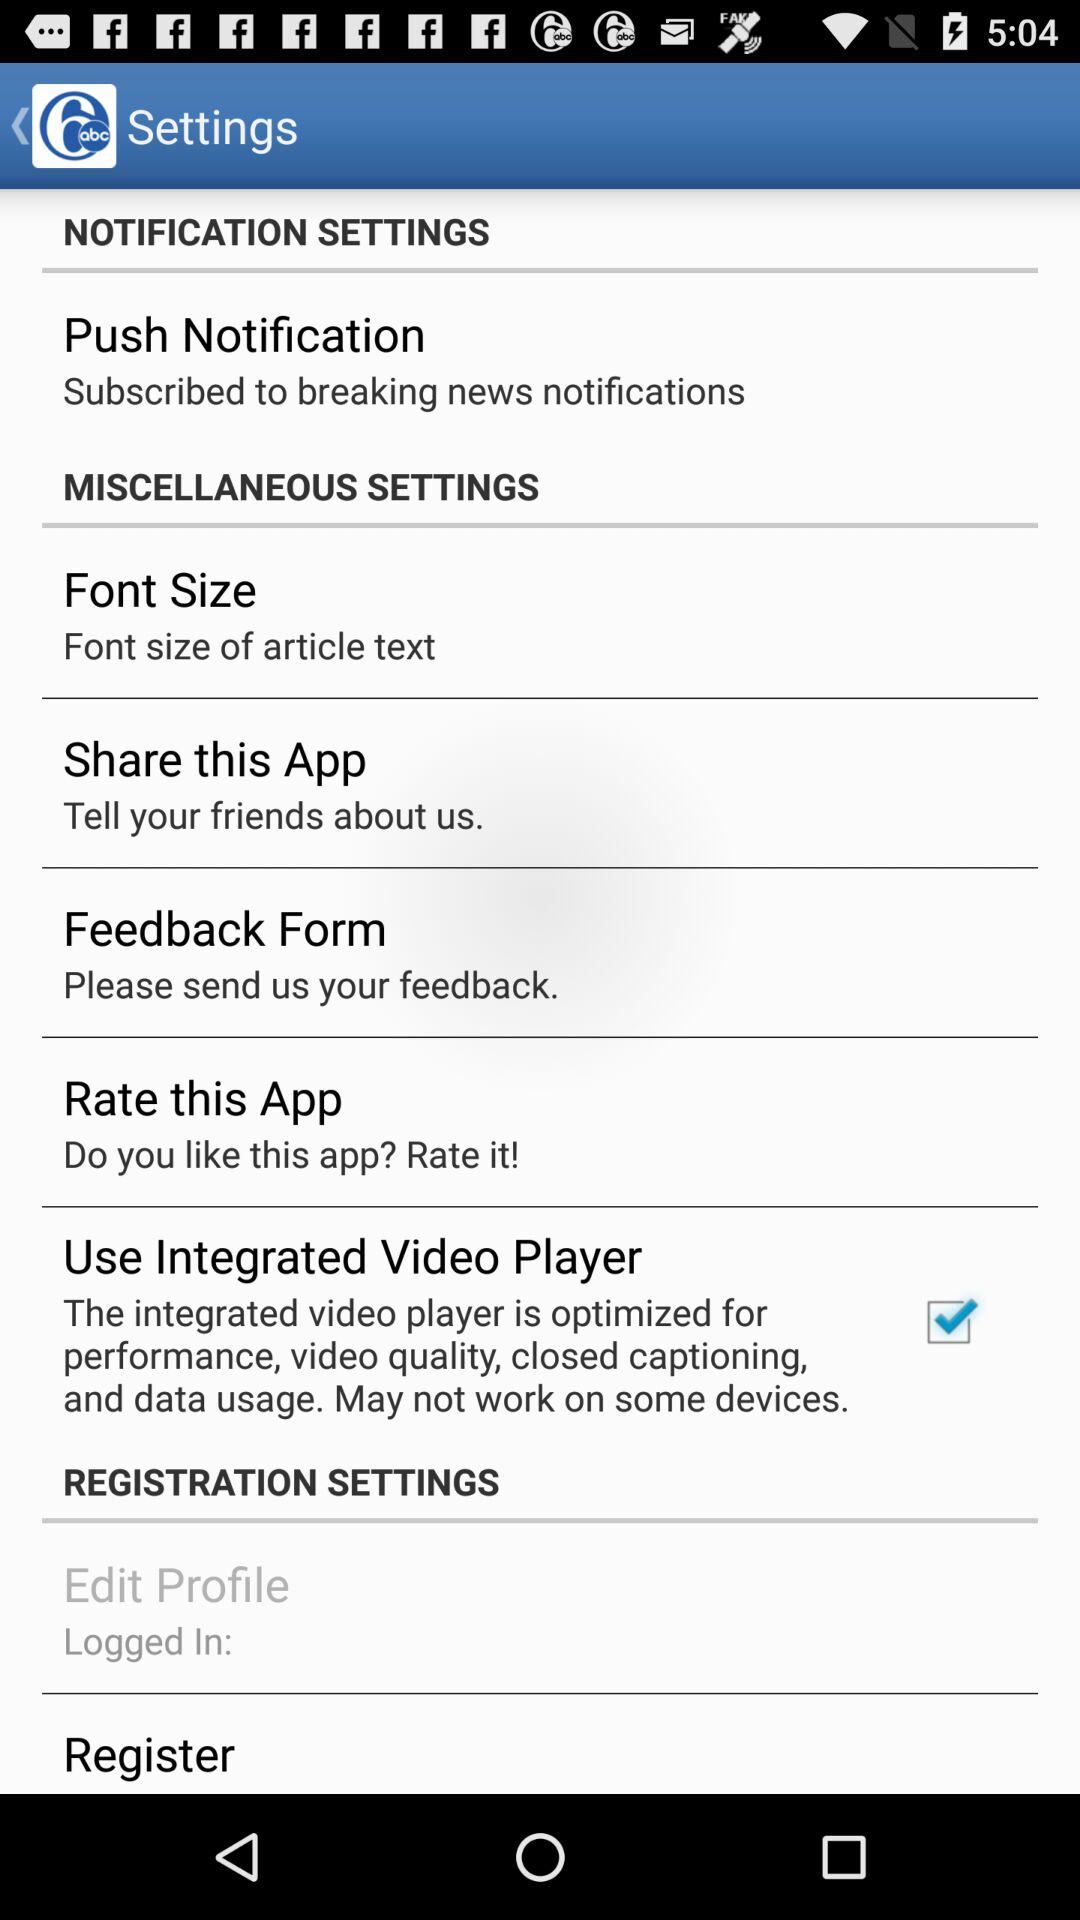With whom can I share this app? You can share this app with your friends. 